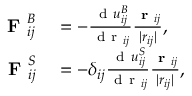Convert formula to latex. <formula><loc_0><loc_0><loc_500><loc_500>\begin{array} { r l } { F _ { i j } ^ { B } } & = - \frac { d u _ { i j } ^ { B } } { d r _ { i j } } \frac { r _ { i j } } { | r _ { i j } | } , } \\ { F _ { i j } ^ { S } } & = - \delta _ { i j } \frac { d u _ { i j } ^ { S } } { d r _ { i j } } \frac { r _ { i j } } { | r _ { i j } | } , } \end{array}</formula> 